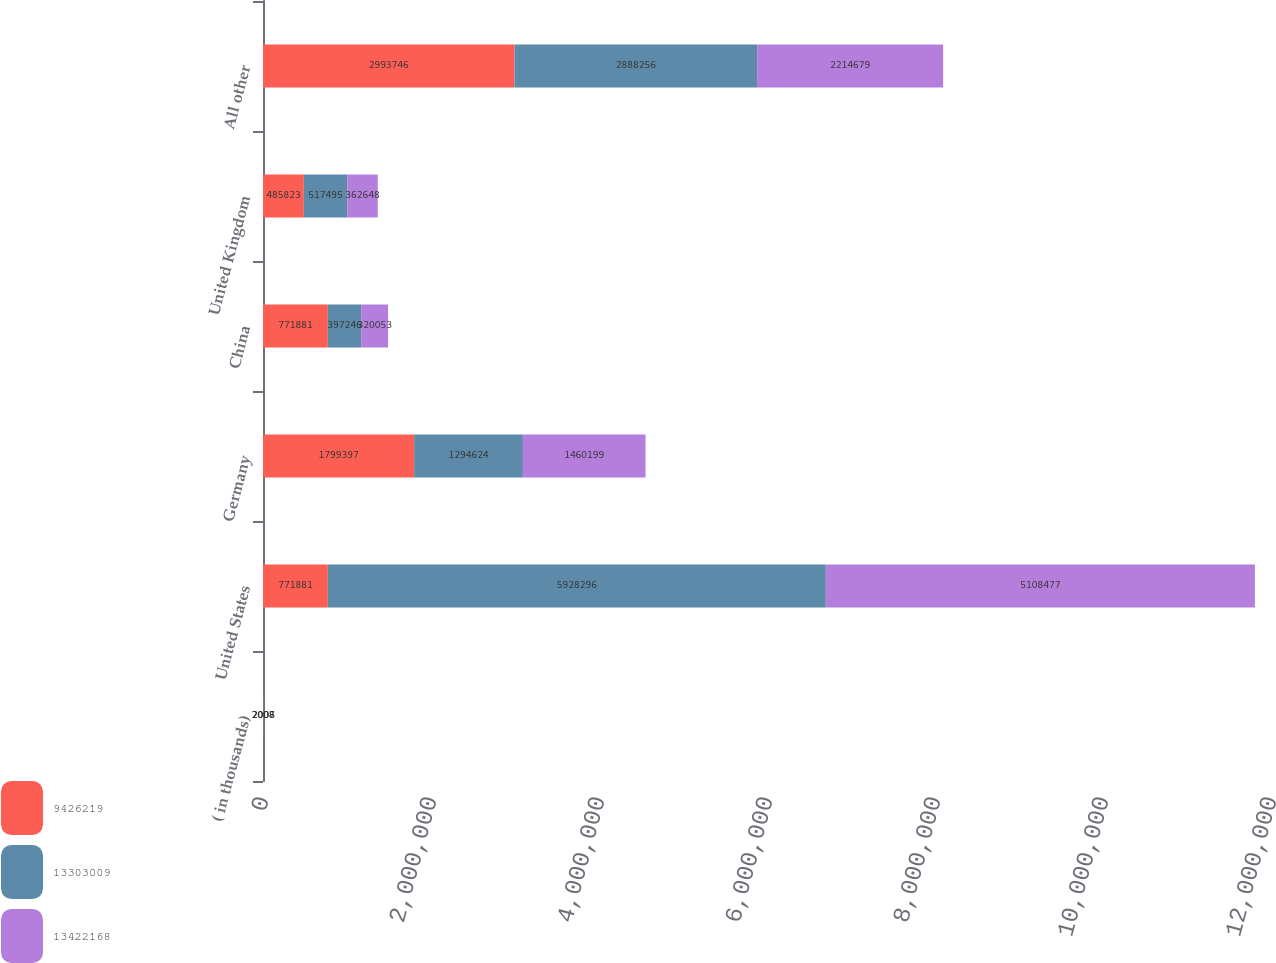<chart> <loc_0><loc_0><loc_500><loc_500><stacked_bar_chart><ecel><fcel>( in thousands)<fcel>United States<fcel>Germany<fcel>China<fcel>United Kingdom<fcel>All other<nl><fcel>9.42622e+06<fcel>2008<fcel>771881<fcel>1.7994e+06<fcel>771881<fcel>485823<fcel>2.99375e+06<nl><fcel>1.3303e+07<fcel>2007<fcel>5.9283e+06<fcel>1.29462e+06<fcel>397246<fcel>517495<fcel>2.88826e+06<nl><fcel>1.34222e+07<fcel>2006<fcel>5.10848e+06<fcel>1.4602e+06<fcel>320053<fcel>362648<fcel>2.21468e+06<nl></chart> 